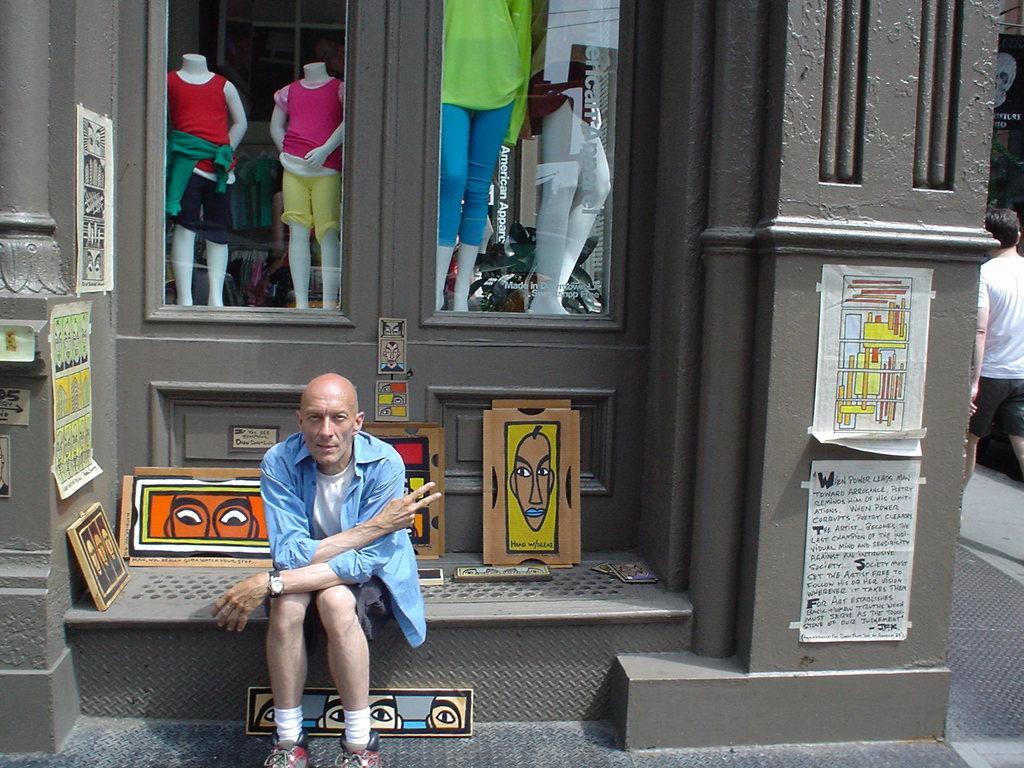In one or two sentences, can you explain what this image depicts? There is a person in blue color t-shirt, sitting and showing a sign. On the right side, there are posters attached to the wall of a building which is having glass windows. Through this windows, we can see there are dolls which are having dresses. Beside these windows, there are posters pasted on the wall and there are paintings. In the background, there is a person in white color t-shirt, walking on the road. 